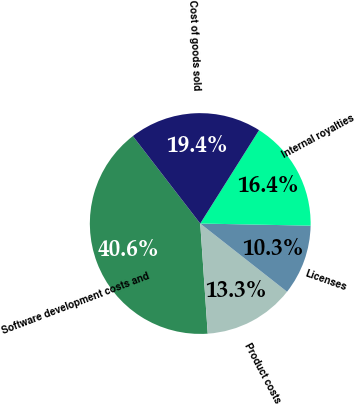Convert chart to OTSL. <chart><loc_0><loc_0><loc_500><loc_500><pie_chart><fcel>Software development costs and<fcel>Product costs<fcel>Licenses<fcel>Internal royalties<fcel>Cost of goods sold<nl><fcel>40.63%<fcel>13.32%<fcel>10.29%<fcel>16.36%<fcel>19.39%<nl></chart> 